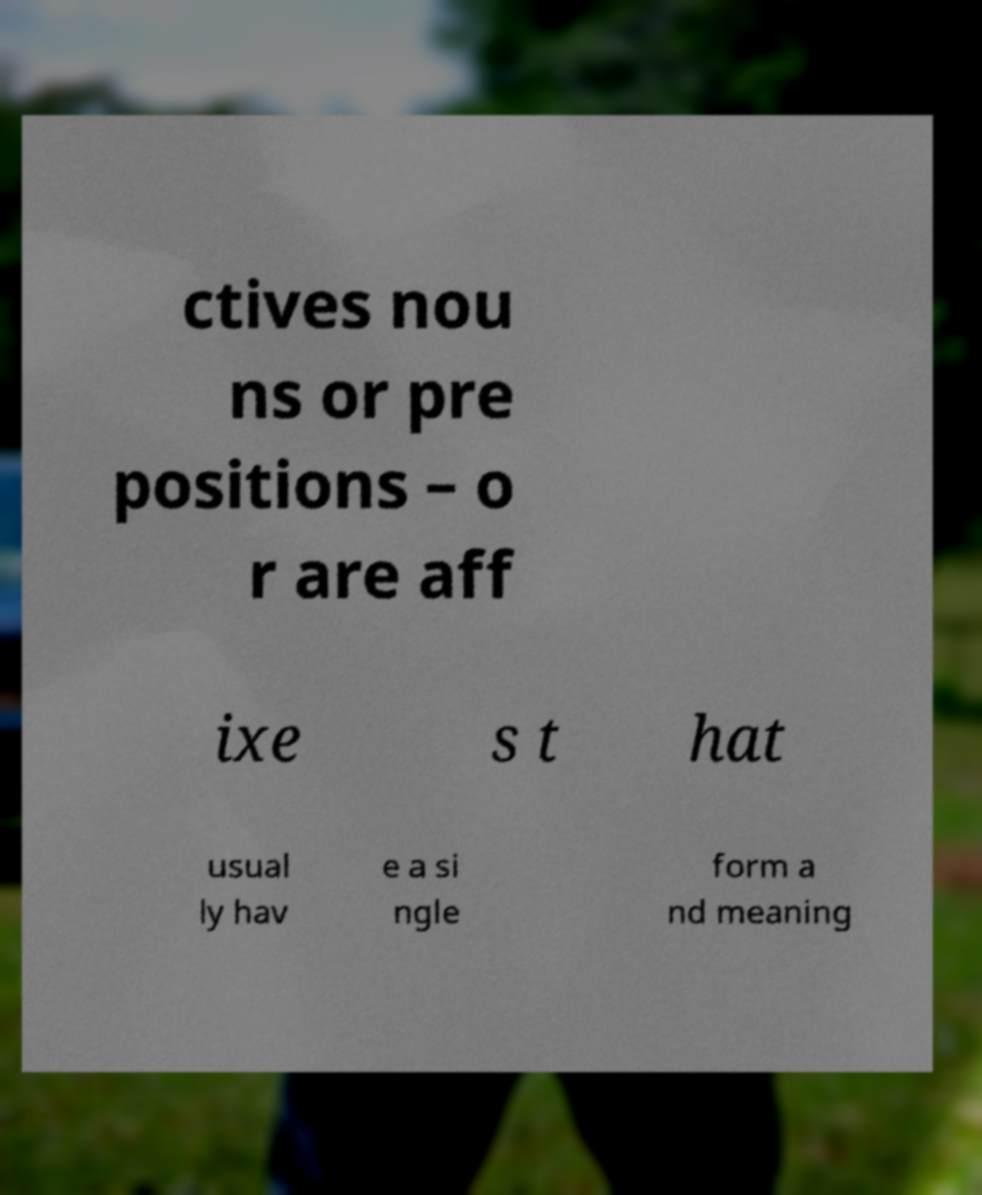For documentation purposes, I need the text within this image transcribed. Could you provide that? ctives nou ns or pre positions – o r are aff ixe s t hat usual ly hav e a si ngle form a nd meaning 